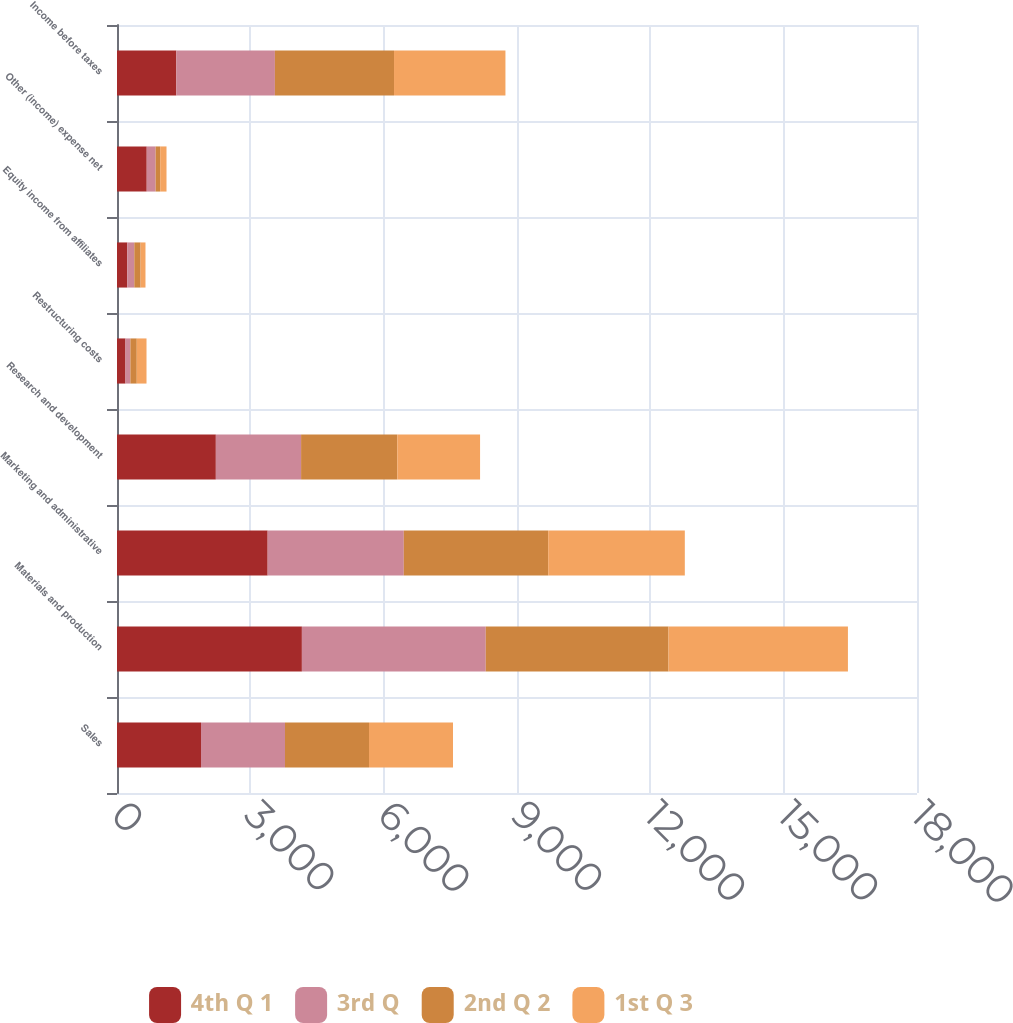Convert chart to OTSL. <chart><loc_0><loc_0><loc_500><loc_500><stacked_bar_chart><ecel><fcel>Sales<fcel>Materials and production<fcel>Marketing and administrative<fcel>Research and development<fcel>Restructuring costs<fcel>Equity income from affiliates<fcel>Other (income) expense net<fcel>Income before taxes<nl><fcel>4th Q 1<fcel>1890<fcel>4160<fcel>3390<fcel>2224<fcel>191<fcel>231<fcel>669<fcel>1335<nl><fcel>3rd Q<fcel>1890<fcel>4137<fcel>3063<fcel>1918<fcel>110<fcel>158<fcel>200<fcel>2218<nl><fcel>2nd Q 2<fcel>1890<fcel>4112<fcel>3249<fcel>2165<fcel>144<fcel>142<fcel>103<fcel>2680<nl><fcel>1st Q 3<fcel>1890<fcel>4037<fcel>3074<fcel>1862<fcel>219<fcel>110<fcel>142<fcel>2507<nl></chart> 